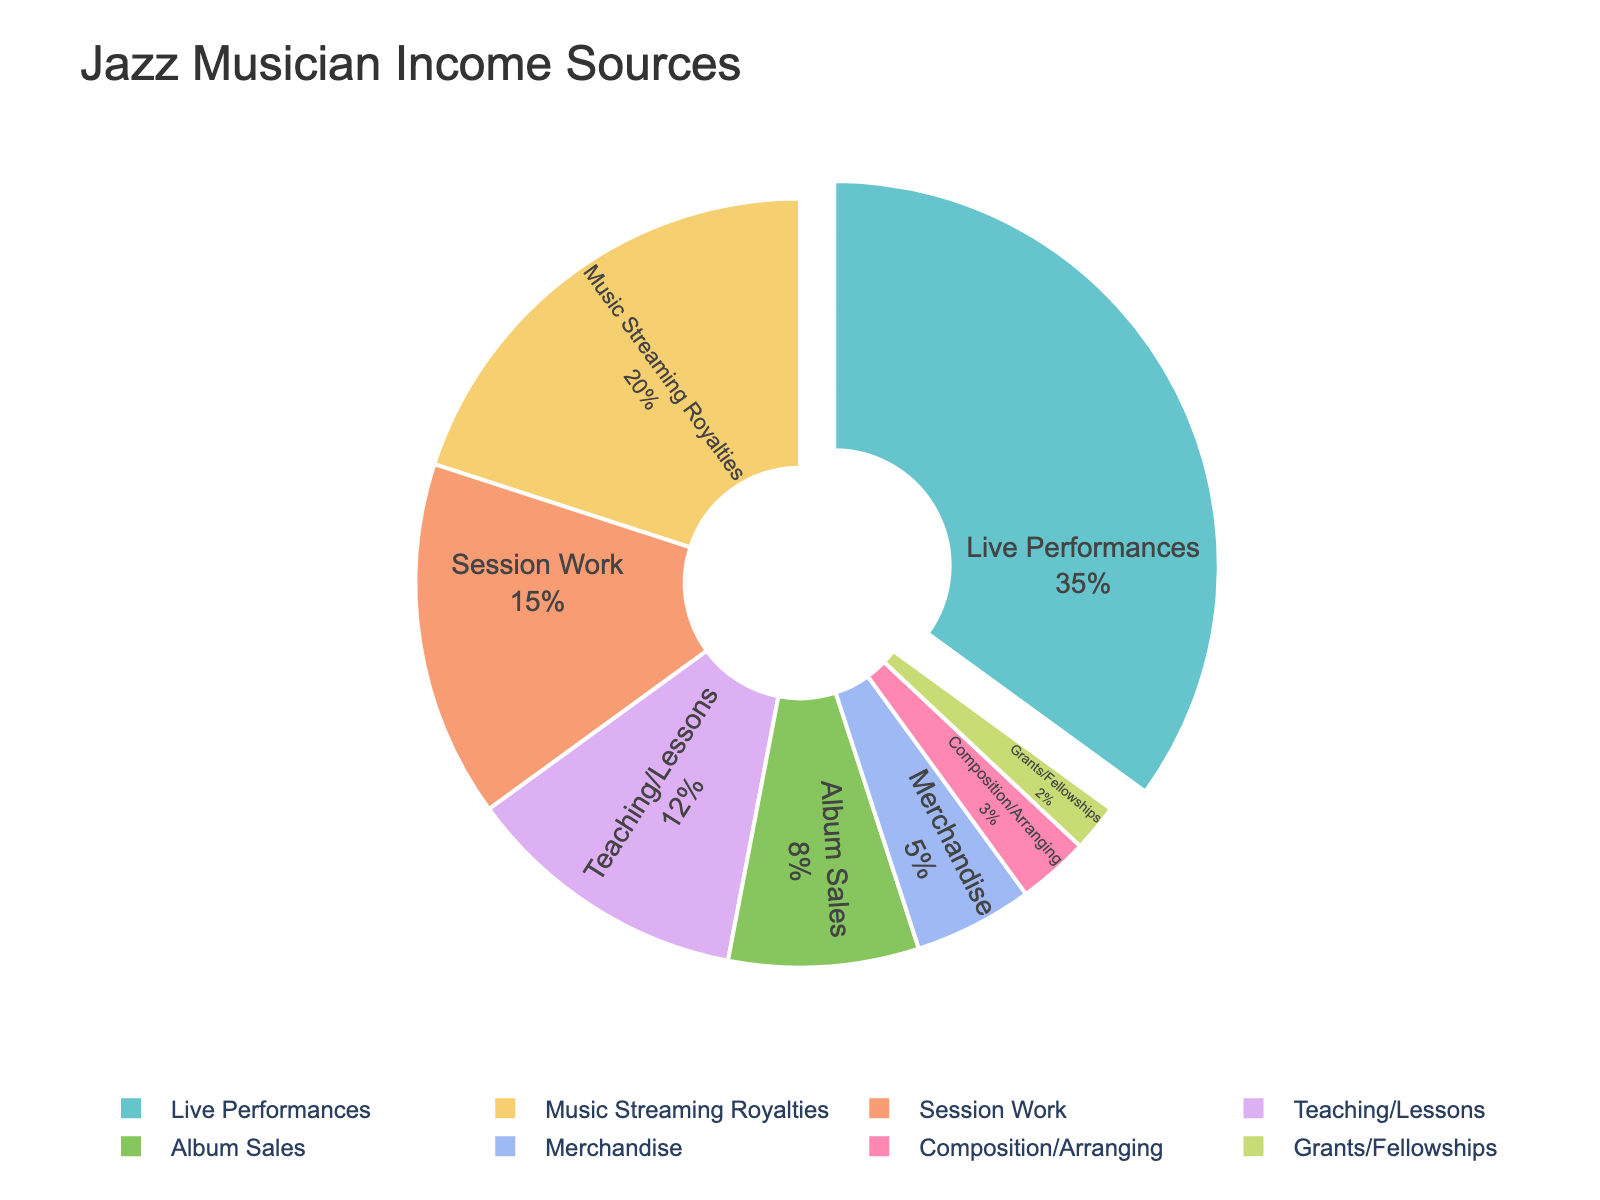Which income source contributes the most to a jazz musician’s income? Looking at the pie chart, the segment representing "Live Performances" is the largest portion.
Answer: Live Performances What is the combined percentage of income from Teaching/Lessons and Session Work? Adding the two percentages together: Teaching/Lessons contributes 12% and Session Work contributes 15%, thus the combined percentage is 12 + 15 = 27%.
Answer: 27% Which income source has the smallest contribution, and what is its percentage? The smallest segment in the pie chart is "Grants/Fellowships". Its percentage is given in the data.
Answer: Grants/Fellowships, 2% How does the percentage of income from Album Sales compare to that from Music Streaming Royalties? Album Sales contribute 8%, while Music Streaming Royalties contribute 20%. By comparison, Streaming Royalties is 20% - 8% = 12% more.
Answer: Music Streaming Royalties is 12% more Which two income sources combined give more than half of the total income? "Live Performances" contribute 35% and "Music Streaming Royalties" contribute 20%. Together, they account for 35 + 20 = 55%, which is more than half.
Answer: Live Performances and Music Streaming Royalties Is the contribution from Merchandise more or less than from Teaching/Lessons, and by how much? Merchandise contributes 5% and Teaching/Lessons contributes 12%. The difference is 12% - 5% = 7%.
Answer: Less, by 7% What are the percentages of income derived from non-performance-related activities (Teaching/Lessons, Composition/Arranging, Grants/Fellowships)? Summing these percentages: Teaching/Lessons = 12%, Composition/Arranging = 3%, and Grants/Fellowships = 2%, so 12 + 3 + 2 = 17%.
Answer: 17% What percentage of income comes from both Album Sales and Merchandise combined? Adding the two percentages together: Album Sales contribute 8% and Merchandise contributes 5%, thus the combined income is 8 + 5 = 13%.
Answer: 13% How much more does Live Performance contribute to a musician's income compared to Composition/Arranging? Live Performances contribute 35% and Composition/Arranging 3%. The difference is 35% - 3% = 32%.
Answer: 32% If a jazz musician wants to maximize their income sources, which two should they focus on based on the pie chart? The two largest segments in the pie chart are for "Live Performances" (35%) and "Music Streaming Royalties" (20%), so they should focus on these two.
Answer: Live Performances and Music Streaming Royalties 